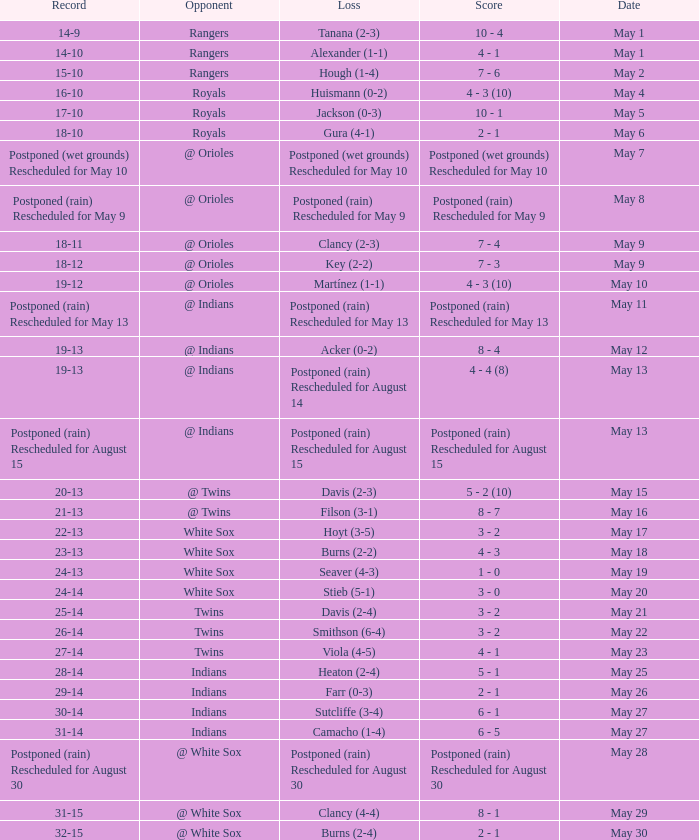What was date of the game when the record was 31-15? May 29. I'm looking to parse the entire table for insights. Could you assist me with that? {'header': ['Record', 'Opponent', 'Loss', 'Score', 'Date'], 'rows': [['14-9', 'Rangers', 'Tanana (2-3)', '10 - 4', 'May 1'], ['14-10', 'Rangers', 'Alexander (1-1)', '4 - 1', 'May 1'], ['15-10', 'Rangers', 'Hough (1-4)', '7 - 6', 'May 2'], ['16-10', 'Royals', 'Huismann (0-2)', '4 - 3 (10)', 'May 4'], ['17-10', 'Royals', 'Jackson (0-3)', '10 - 1', 'May 5'], ['18-10', 'Royals', 'Gura (4-1)', '2 - 1', 'May 6'], ['Postponed (wet grounds) Rescheduled for May 10', '@ Orioles', 'Postponed (wet grounds) Rescheduled for May 10', 'Postponed (wet grounds) Rescheduled for May 10', 'May 7'], ['Postponed (rain) Rescheduled for May 9', '@ Orioles', 'Postponed (rain) Rescheduled for May 9', 'Postponed (rain) Rescheduled for May 9', 'May 8'], ['18-11', '@ Orioles', 'Clancy (2-3)', '7 - 4', 'May 9'], ['18-12', '@ Orioles', 'Key (2-2)', '7 - 3', 'May 9'], ['19-12', '@ Orioles', 'Martínez (1-1)', '4 - 3 (10)', 'May 10'], ['Postponed (rain) Rescheduled for May 13', '@ Indians', 'Postponed (rain) Rescheduled for May 13', 'Postponed (rain) Rescheduled for May 13', 'May 11'], ['19-13', '@ Indians', 'Acker (0-2)', '8 - 4', 'May 12'], ['19-13', '@ Indians', 'Postponed (rain) Rescheduled for August 14', '4 - 4 (8)', 'May 13'], ['Postponed (rain) Rescheduled for August 15', '@ Indians', 'Postponed (rain) Rescheduled for August 15', 'Postponed (rain) Rescheduled for August 15', 'May 13'], ['20-13', '@ Twins', 'Davis (2-3)', '5 - 2 (10)', 'May 15'], ['21-13', '@ Twins', 'Filson (3-1)', '8 - 7', 'May 16'], ['22-13', 'White Sox', 'Hoyt (3-5)', '3 - 2', 'May 17'], ['23-13', 'White Sox', 'Burns (2-2)', '4 - 3', 'May 18'], ['24-13', 'White Sox', 'Seaver (4-3)', '1 - 0', 'May 19'], ['24-14', 'White Sox', 'Stieb (5-1)', '3 - 0', 'May 20'], ['25-14', 'Twins', 'Davis (2-4)', '3 - 2', 'May 21'], ['26-14', 'Twins', 'Smithson (6-4)', '3 - 2', 'May 22'], ['27-14', 'Twins', 'Viola (4-5)', '4 - 1', 'May 23'], ['28-14', 'Indians', 'Heaton (2-4)', '5 - 1', 'May 25'], ['29-14', 'Indians', 'Farr (0-3)', '2 - 1', 'May 26'], ['30-14', 'Indians', 'Sutcliffe (3-4)', '6 - 1', 'May 27'], ['31-14', 'Indians', 'Camacho (1-4)', '6 - 5', 'May 27'], ['Postponed (rain) Rescheduled for August 30', '@ White Sox', 'Postponed (rain) Rescheduled for August 30', 'Postponed (rain) Rescheduled for August 30', 'May 28'], ['31-15', '@ White Sox', 'Clancy (4-4)', '8 - 1', 'May 29'], ['32-15', '@ White Sox', 'Burns (2-4)', '2 - 1', 'May 30']]} 